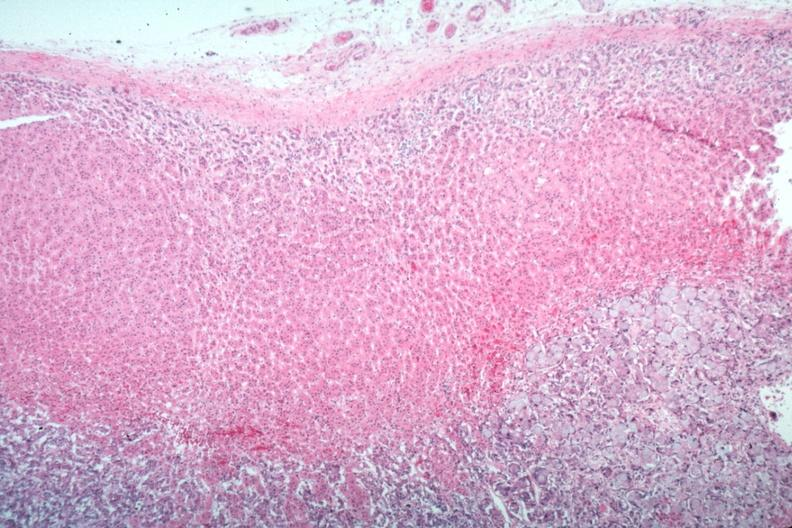what is present?
Answer the question using a single word or phrase. Adrenal 